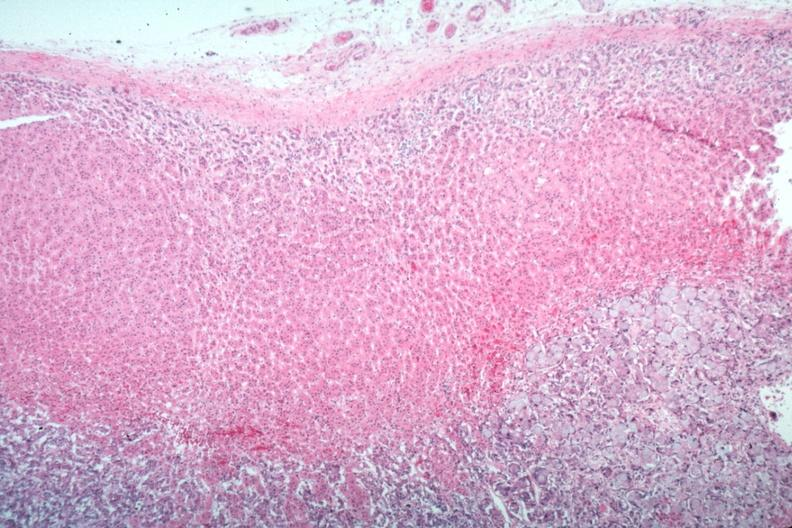what is present?
Answer the question using a single word or phrase. Adrenal 